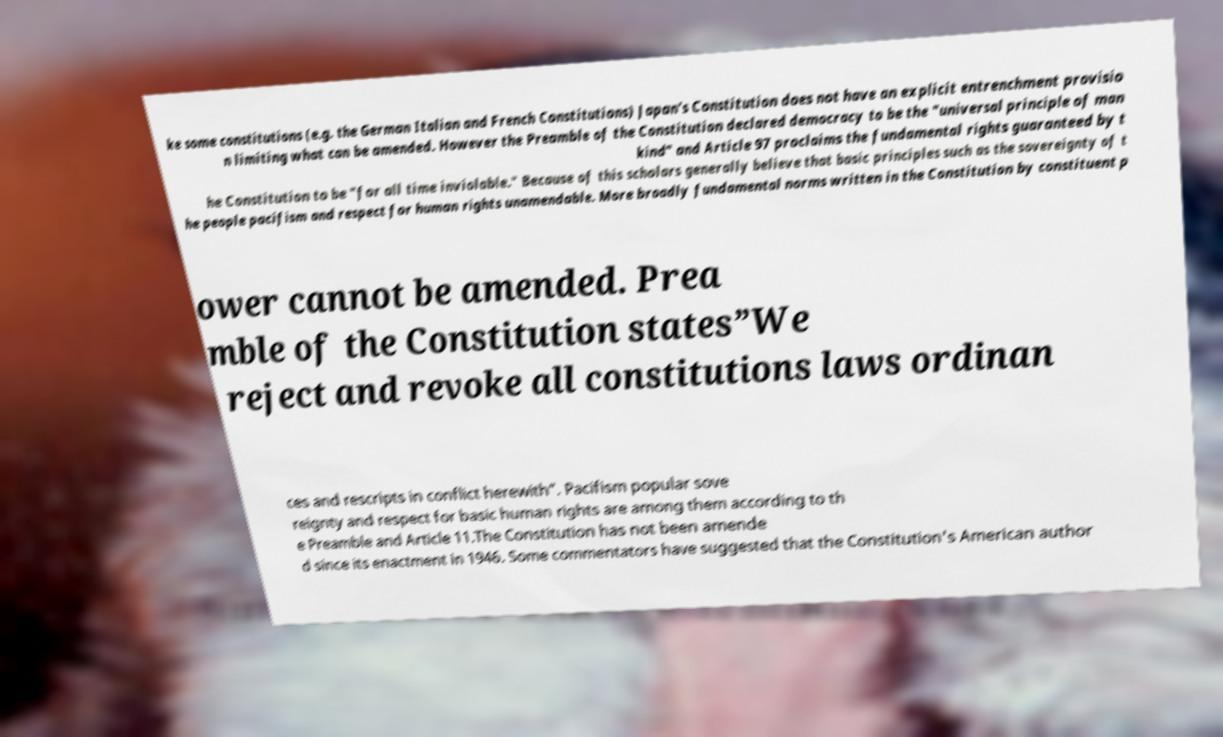There's text embedded in this image that I need extracted. Can you transcribe it verbatim? ke some constitutions (e.g. the German Italian and French Constitutions) Japan's Constitution does not have an explicit entrenchment provisio n limiting what can be amended. However the Preamble of the Constitution declared democracy to be the "universal principle of man kind" and Article 97 proclaims the fundamental rights guaranteed by t he Constitution to be "for all time inviolable." Because of this scholars generally believe that basic principles such as the sovereignty of t he people pacifism and respect for human rights unamendable. More broadly fundamental norms written in the Constitution by constituent p ower cannot be amended. Prea mble of the Constitution states”We reject and revoke all constitutions laws ordinan ces and rescripts in conflict herewith”. Pacifism popular sove reignty and respect for basic human rights are among them according to th e Preamble and Article 11.The Constitution has not been amende d since its enactment in 1946. Some commentators have suggested that the Constitution's American author 